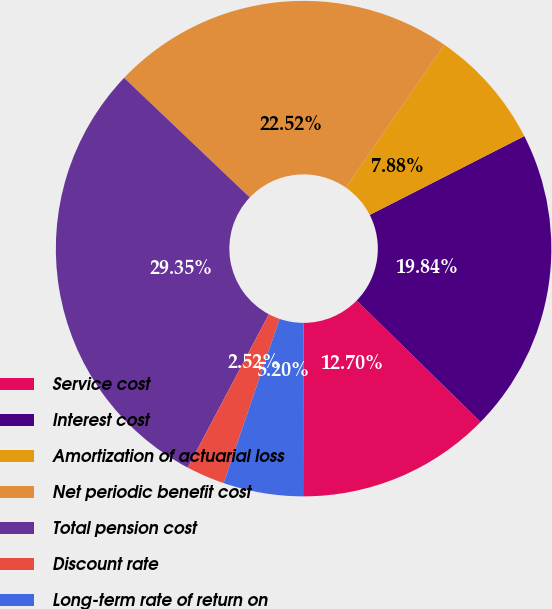<chart> <loc_0><loc_0><loc_500><loc_500><pie_chart><fcel>Service cost<fcel>Interest cost<fcel>Amortization of actuarial loss<fcel>Net periodic benefit cost<fcel>Total pension cost<fcel>Discount rate<fcel>Long-term rate of return on<nl><fcel>12.7%<fcel>19.84%<fcel>7.88%<fcel>22.52%<fcel>29.36%<fcel>2.52%<fcel>5.2%<nl></chart> 